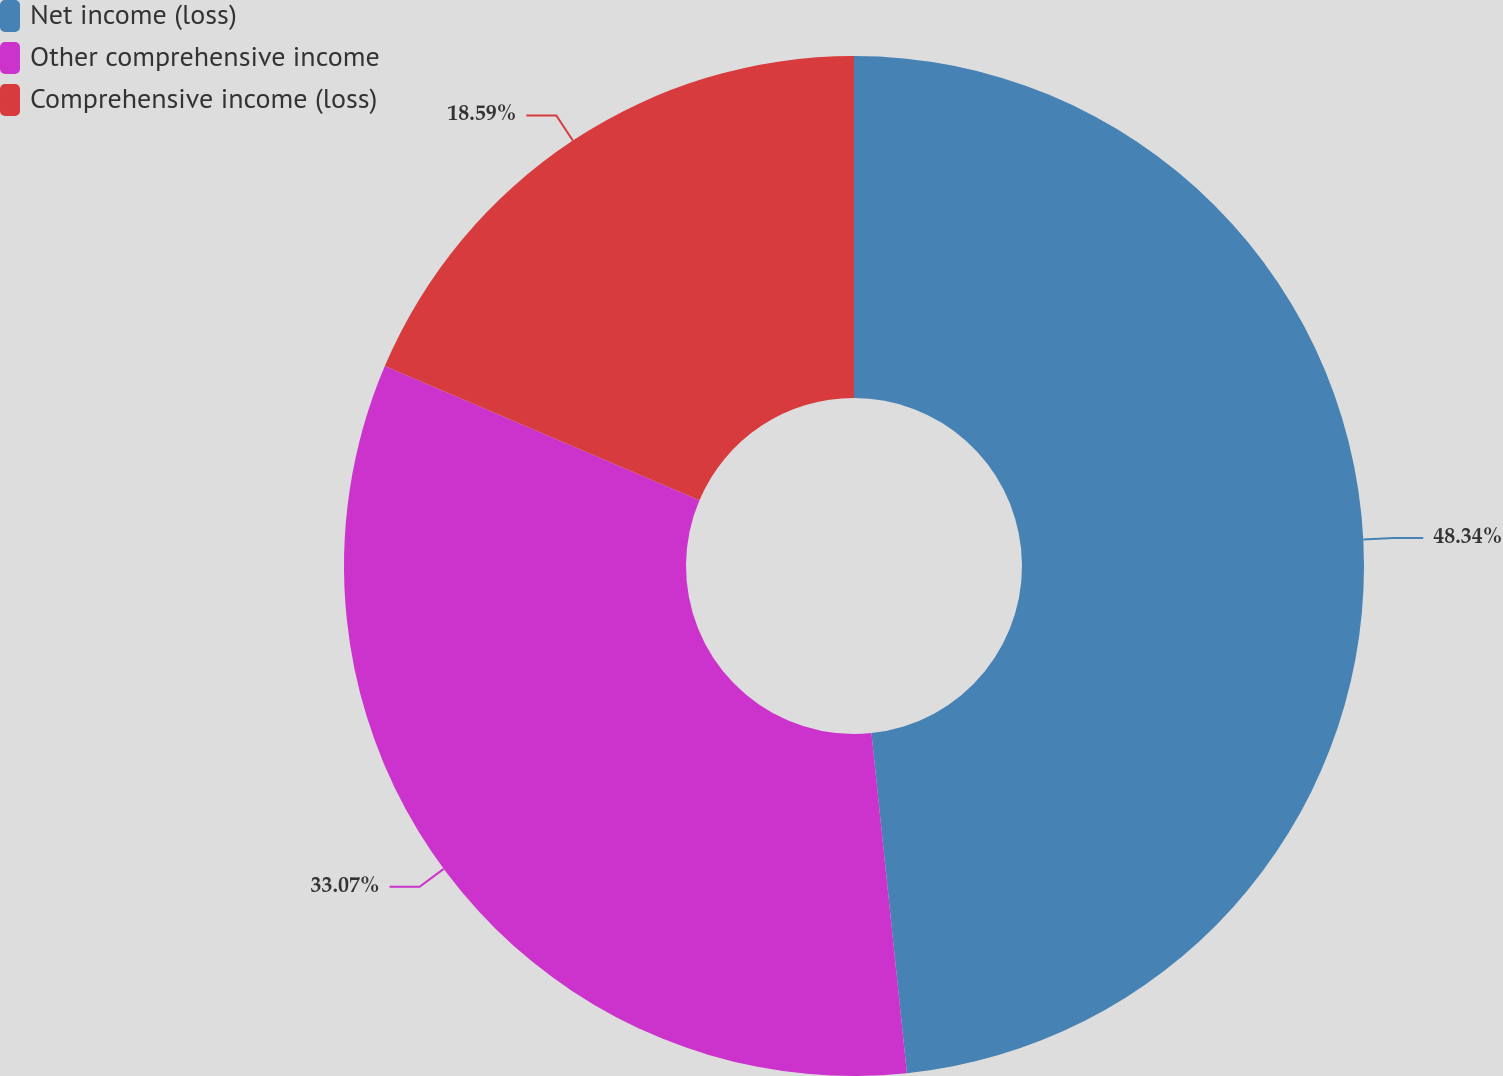Convert chart. <chart><loc_0><loc_0><loc_500><loc_500><pie_chart><fcel>Net income (loss)<fcel>Other comprehensive income<fcel>Comprehensive income (loss)<nl><fcel>48.35%<fcel>33.07%<fcel>18.59%<nl></chart> 